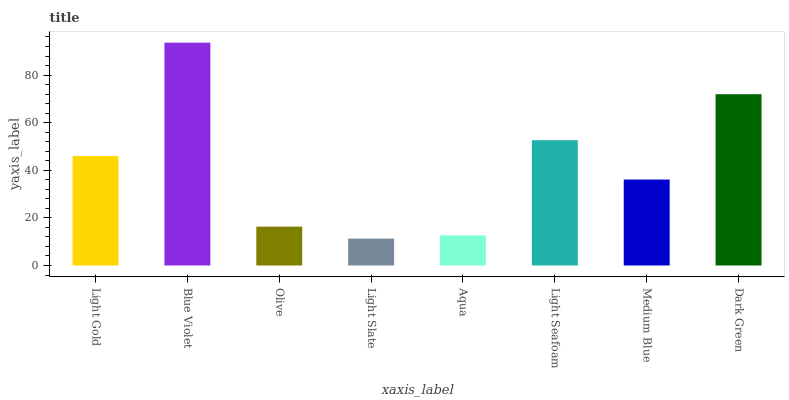Is Olive the minimum?
Answer yes or no. No. Is Olive the maximum?
Answer yes or no. No. Is Blue Violet greater than Olive?
Answer yes or no. Yes. Is Olive less than Blue Violet?
Answer yes or no. Yes. Is Olive greater than Blue Violet?
Answer yes or no. No. Is Blue Violet less than Olive?
Answer yes or no. No. Is Light Gold the high median?
Answer yes or no. Yes. Is Medium Blue the low median?
Answer yes or no. Yes. Is Light Seafoam the high median?
Answer yes or no. No. Is Olive the low median?
Answer yes or no. No. 